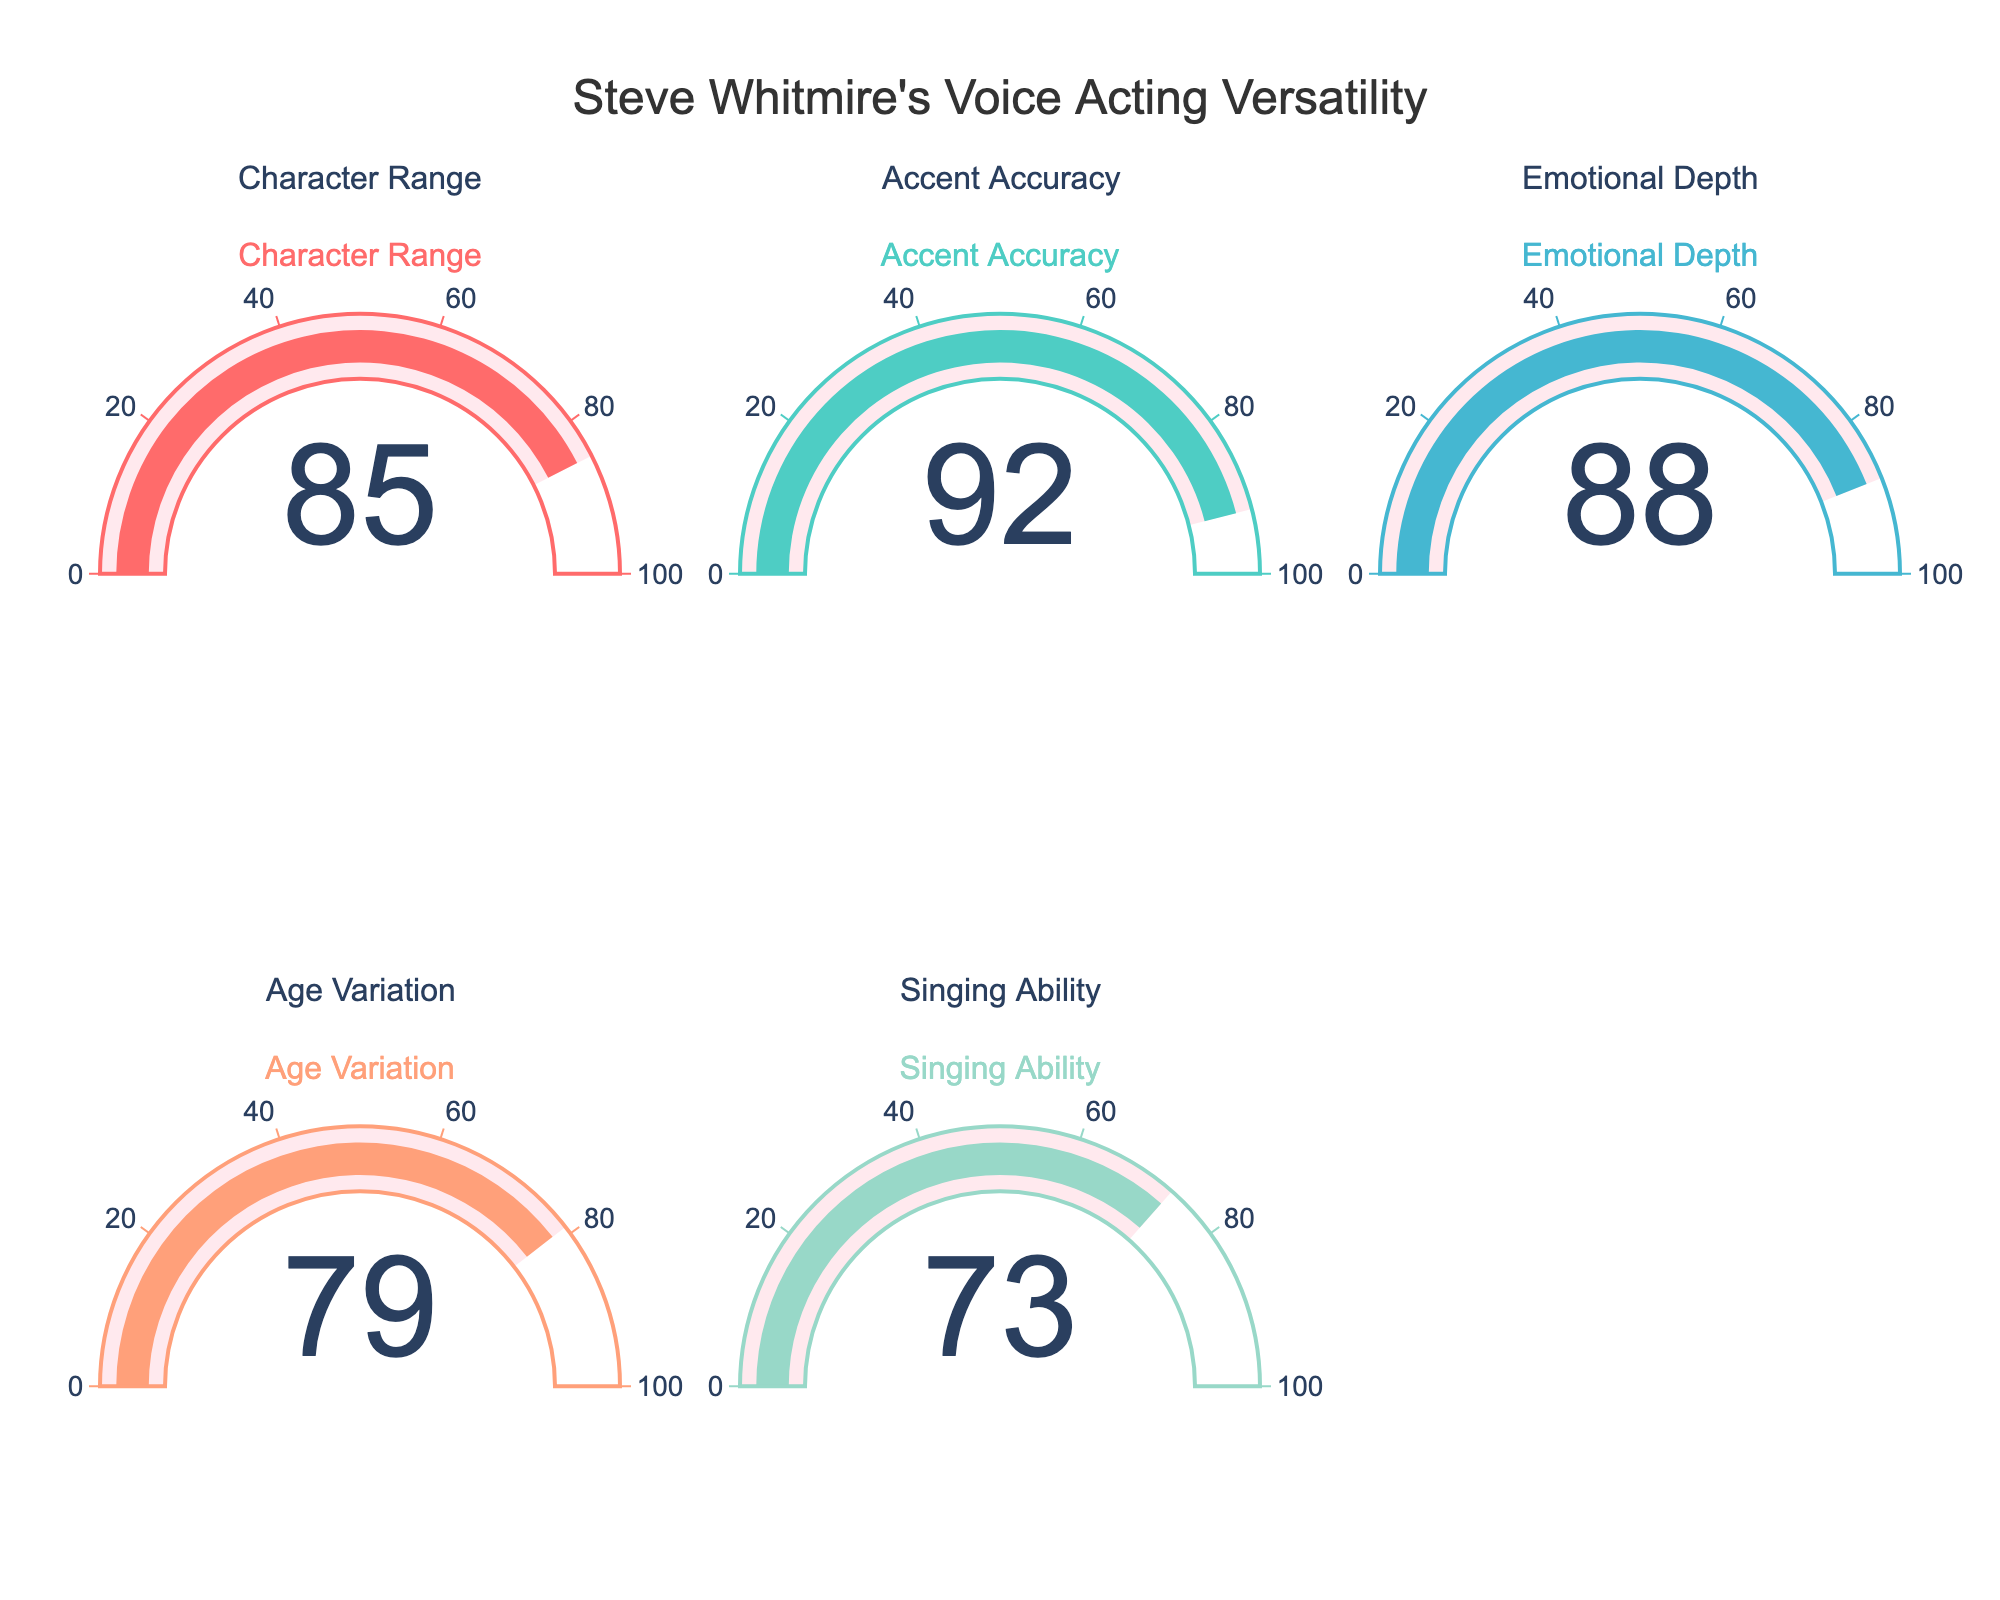What is the title of the figure? The title is prominently displayed at the top center of the figure. It reads "Steve Whitmire's Voice Acting Versatility."
Answer: Steve Whitmire's Voice Acting Versatility What is the highest score represented in the gauge chart? By examining each gauge, the highest score is shown in the "Accent Accuracy" category, which has a score of 92.
Answer: 92 Which category has the lowest score? By examining the scores in each gauge, the "Singing Ability" category has the lowest score of 73.
Answer: Singing Ability What is the average score across all categories? To find the average score, add all the scores (85 + 92 + 88 + 79 + 73) and divide by the number of categories (5). The sum is 417, and 417 divided by 5 equals 83.4.
Answer: 83.4 Which two categories have the most similar scores? By looking at the gauge values, "Character Range" and "Emotional Depth" have scores of 85 and 88, with a difference of 3, making them the most similar.
Answer: Character Range and Emotional Depth Is the score for "Age Variation" above the median score of all categories? First, list the scores (73, 79, 85, 88, 92) and identify the median, which is the middle value, 85. The score for "Age Variation" is 79, which is less than 85.
Answer: No How many categories have a score above 80? By checking each gauge, "Character Range" (85), "Accent Accuracy" (92), and "Emotional Depth" (88) have scores above 80. This makes three categories.
Answer: 3 What is the range of scores represented in the figure? The range is calculated by subtracting the lowest score (73) from the highest score (92). The range is 92 - 73 = 19.
Answer: 19 Which category would you improve if you could raise one of the scores to match the highest score in another category? The category with the lowest score ("Singing Ability" at 73) could be improved to match the highest score ("Accent Accuracy" at 92).
Answer: Singing Ability to 92 How much higher is the "Accent Accuracy" score compared to the "Age Variation" score? Subtract the "Age Variation" score (79) from the "Accent Accuracy" score (92). The difference is 92 - 79 = 13.
Answer: 13 